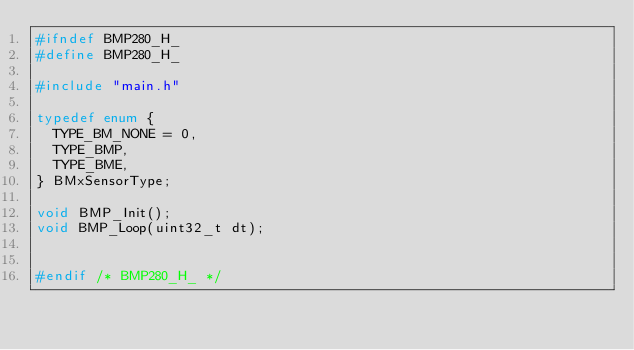<code> <loc_0><loc_0><loc_500><loc_500><_C_>#ifndef BMP280_H_
#define BMP280_H_

#include "main.h"

typedef enum {
  TYPE_BM_NONE = 0,
  TYPE_BMP,
  TYPE_BME,
} BMxSensorType;

void BMP_Init();
void BMP_Loop(uint32_t dt);


#endif /* BMP280_H_ */
</code> 